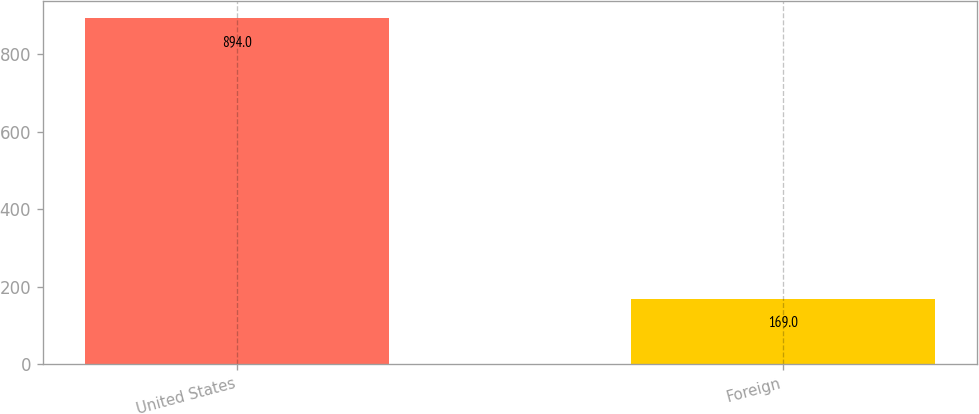Convert chart. <chart><loc_0><loc_0><loc_500><loc_500><bar_chart><fcel>United States<fcel>Foreign<nl><fcel>894<fcel>169<nl></chart> 